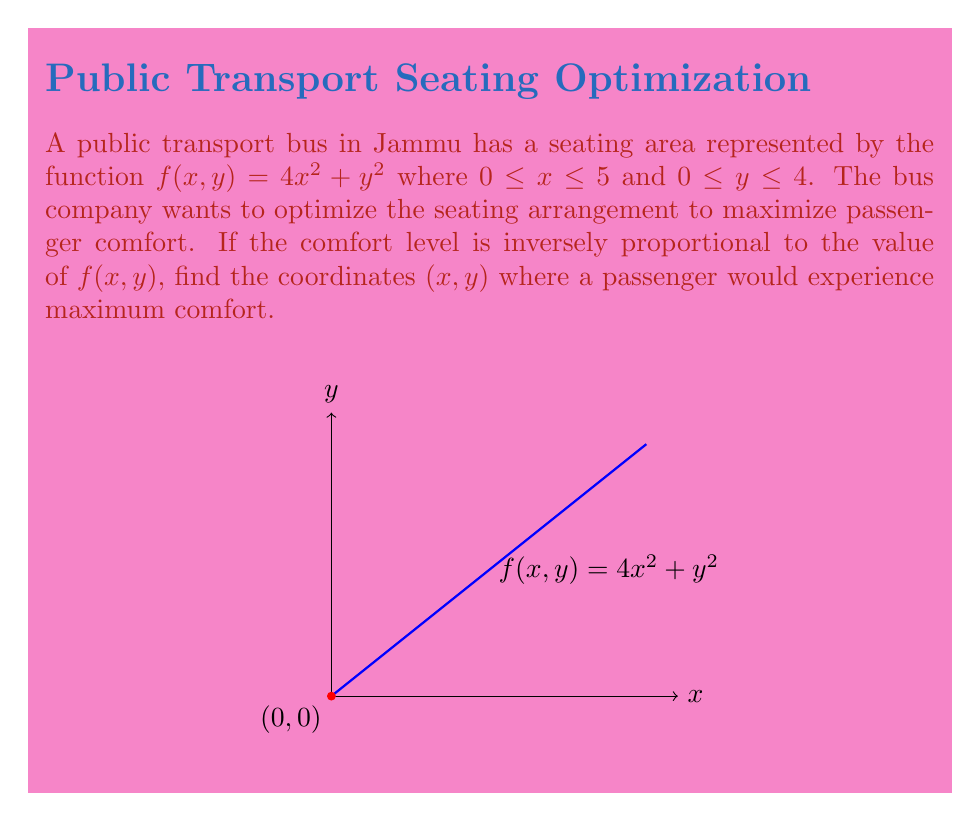What is the answer to this math problem? To find the point of maximum comfort, we need to minimize the function $f(x,y) = 4x^2 + y^2$. We'll use the following steps:

1) First, we need to find the critical points by taking partial derivatives:

   $$\frac{\partial f}{\partial x} = 8x$$
   $$\frac{\partial f}{\partial y} = 2y$$

2) Set these equal to zero:

   $8x = 0$ and $2y = 0$

3) Solve:

   $x = 0$ and $y = 0$

4) The critical point is (0,0). However, we need to check the boundaries as well, since the domain is restricted.

5) Check the edges:
   - When $x = 0$, $f(0,y) = y^2$, minimum at $y = 0$
   - When $x = 5$, $f(5,y) = 100 + y^2$, minimum at $y = 0$
   - When $y = 0$, $f(x,0) = 4x^2$, minimum at $x = 0$
   - When $y = 4$, $f(x,4) = 4x^2 + 16$, minimum at $x = 0$

6) The global minimum occurs at (0,0), which is within the domain.

Therefore, the point of maximum comfort is at (0,0).
Answer: (0,0) 